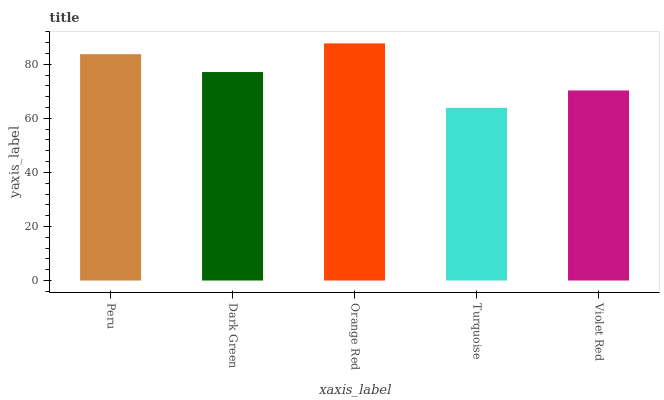Is Dark Green the minimum?
Answer yes or no. No. Is Dark Green the maximum?
Answer yes or no. No. Is Peru greater than Dark Green?
Answer yes or no. Yes. Is Dark Green less than Peru?
Answer yes or no. Yes. Is Dark Green greater than Peru?
Answer yes or no. No. Is Peru less than Dark Green?
Answer yes or no. No. Is Dark Green the high median?
Answer yes or no. Yes. Is Dark Green the low median?
Answer yes or no. Yes. Is Turquoise the high median?
Answer yes or no. No. Is Violet Red the low median?
Answer yes or no. No. 